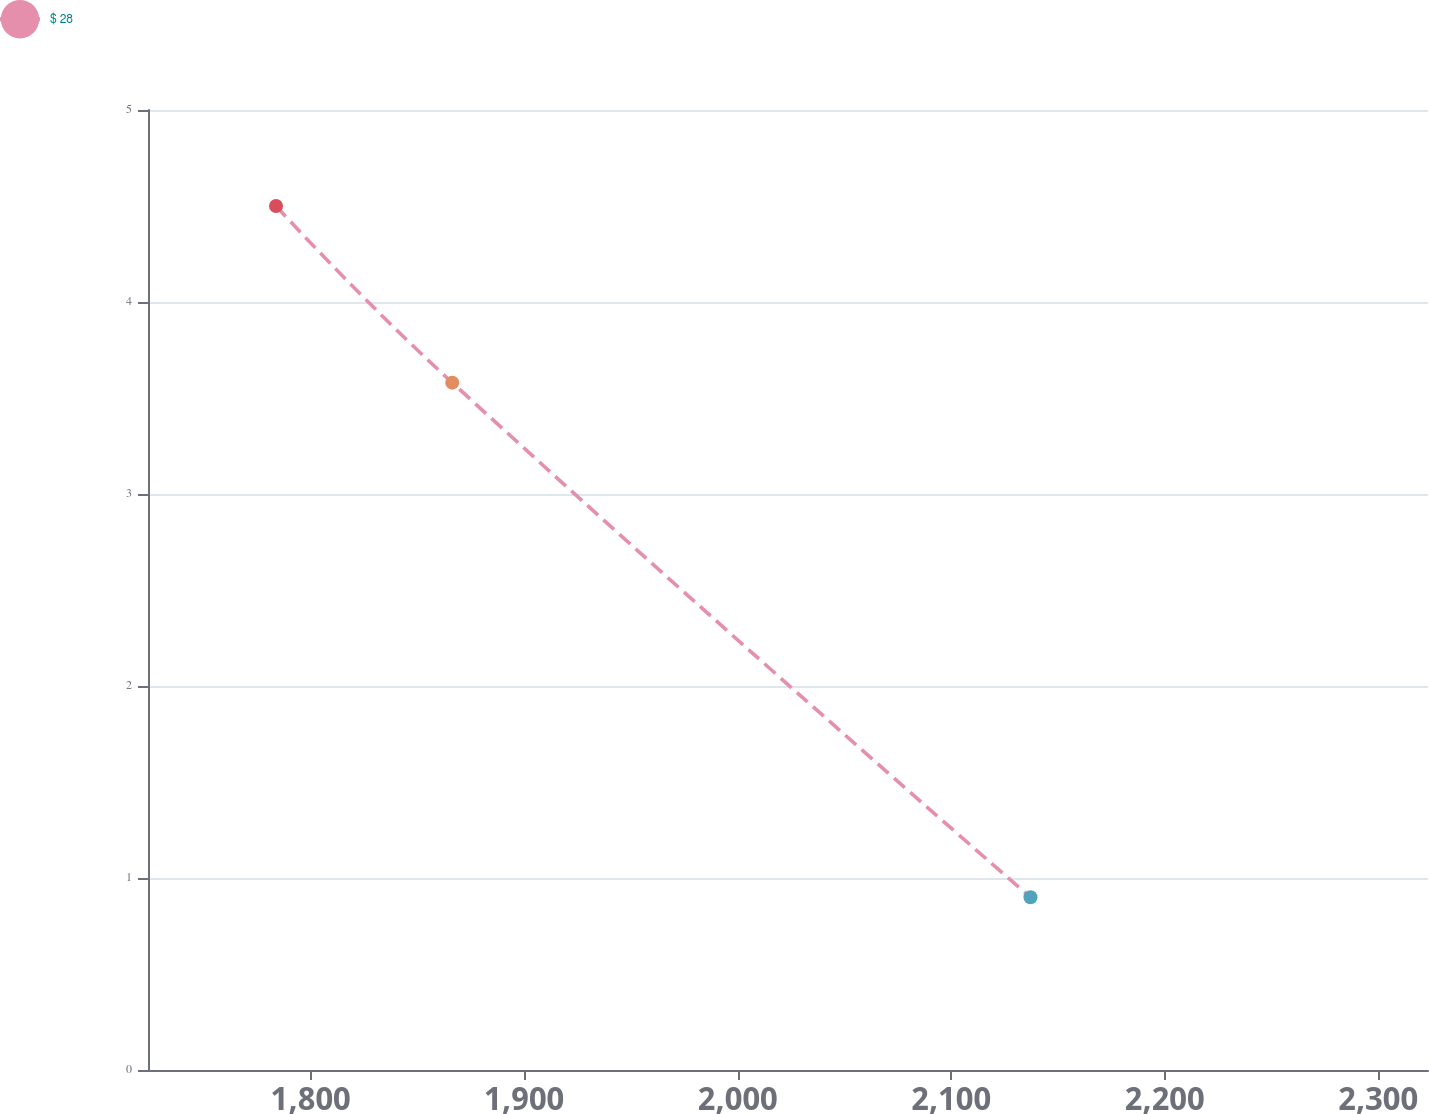Convert chart. <chart><loc_0><loc_0><loc_500><loc_500><line_chart><ecel><fcel>$ 28<nl><fcel>1783.72<fcel>4.5<nl><fcel>1866.27<fcel>3.58<nl><fcel>2137.12<fcel>0.9<nl><fcel>2383.28<fcel>2.01<nl></chart> 